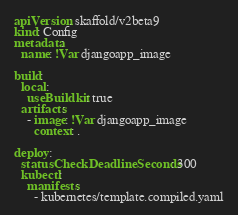<code> <loc_0><loc_0><loc_500><loc_500><_YAML_>apiVersion: skaffold/v2beta9
kind: Config
metadata:
  name: !Var djangoapp_image

build:
  local:
    useBuildkit: true
  artifacts:
    - image: !Var djangoapp_image
      context: .

deploy:
  statusCheckDeadlineSeconds: 300
  kubectl:
    manifests:
      - kubernetes/template.compiled.yaml
</code> 